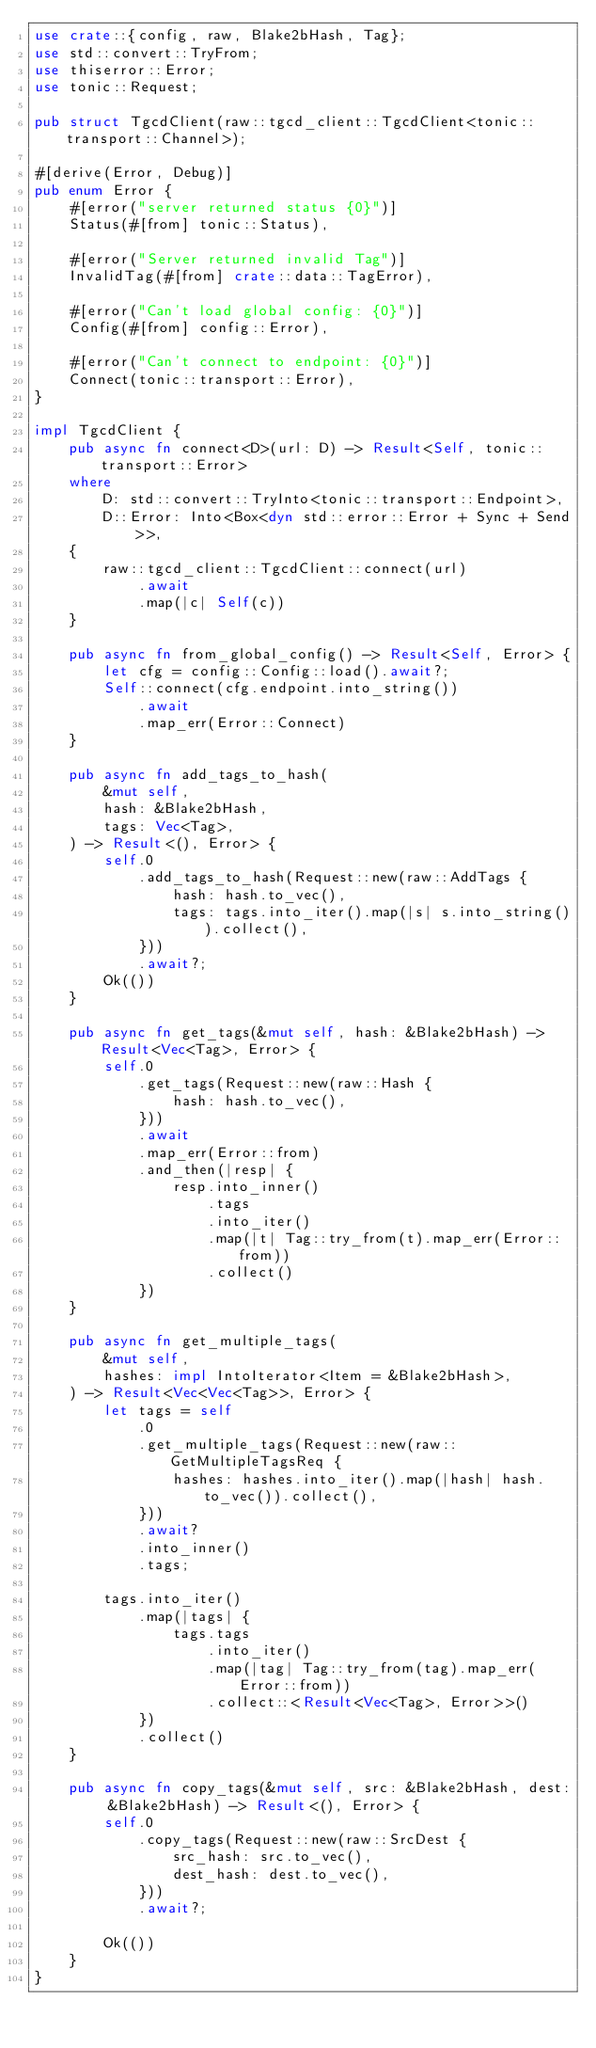Convert code to text. <code><loc_0><loc_0><loc_500><loc_500><_Rust_>use crate::{config, raw, Blake2bHash, Tag};
use std::convert::TryFrom;
use thiserror::Error;
use tonic::Request;

pub struct TgcdClient(raw::tgcd_client::TgcdClient<tonic::transport::Channel>);

#[derive(Error, Debug)]
pub enum Error {
    #[error("server returned status {0}")]
    Status(#[from] tonic::Status),

    #[error("Server returned invalid Tag")]
    InvalidTag(#[from] crate::data::TagError),

    #[error("Can't load global config: {0}")]
    Config(#[from] config::Error),

    #[error("Can't connect to endpoint: {0}")]
    Connect(tonic::transport::Error),
}

impl TgcdClient {
    pub async fn connect<D>(url: D) -> Result<Self, tonic::transport::Error>
    where
        D: std::convert::TryInto<tonic::transport::Endpoint>,
        D::Error: Into<Box<dyn std::error::Error + Sync + Send>>,
    {
        raw::tgcd_client::TgcdClient::connect(url)
            .await
            .map(|c| Self(c))
    }

    pub async fn from_global_config() -> Result<Self, Error> {
        let cfg = config::Config::load().await?;
        Self::connect(cfg.endpoint.into_string())
            .await
            .map_err(Error::Connect)
    }

    pub async fn add_tags_to_hash(
        &mut self,
        hash: &Blake2bHash,
        tags: Vec<Tag>,
    ) -> Result<(), Error> {
        self.0
            .add_tags_to_hash(Request::new(raw::AddTags {
                hash: hash.to_vec(),
                tags: tags.into_iter().map(|s| s.into_string()).collect(),
            }))
            .await?;
        Ok(())
    }

    pub async fn get_tags(&mut self, hash: &Blake2bHash) -> Result<Vec<Tag>, Error> {
        self.0
            .get_tags(Request::new(raw::Hash {
                hash: hash.to_vec(),
            }))
            .await
            .map_err(Error::from)
            .and_then(|resp| {
                resp.into_inner()
                    .tags
                    .into_iter()
                    .map(|t| Tag::try_from(t).map_err(Error::from))
                    .collect()
            })
    }

    pub async fn get_multiple_tags(
        &mut self,
        hashes: impl IntoIterator<Item = &Blake2bHash>,
    ) -> Result<Vec<Vec<Tag>>, Error> {
        let tags = self
            .0
            .get_multiple_tags(Request::new(raw::GetMultipleTagsReq {
                hashes: hashes.into_iter().map(|hash| hash.to_vec()).collect(),
            }))
            .await?
            .into_inner()
            .tags;

        tags.into_iter()
            .map(|tags| {
                tags.tags
                    .into_iter()
                    .map(|tag| Tag::try_from(tag).map_err(Error::from))
                    .collect::<Result<Vec<Tag>, Error>>()
            })
            .collect()
    }

    pub async fn copy_tags(&mut self, src: &Blake2bHash, dest: &Blake2bHash) -> Result<(), Error> {
        self.0
            .copy_tags(Request::new(raw::SrcDest {
                src_hash: src.to_vec(),
                dest_hash: dest.to_vec(),
            }))
            .await?;

        Ok(())
    }
}
</code> 